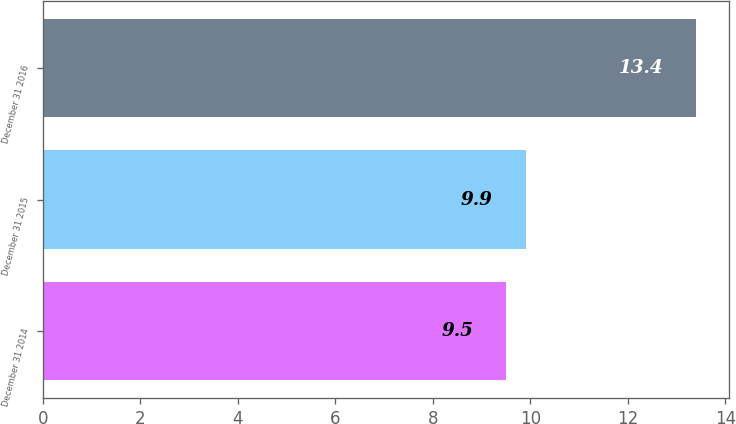Convert chart. <chart><loc_0><loc_0><loc_500><loc_500><bar_chart><fcel>December 31 2014<fcel>December 31 2015<fcel>December 31 2016<nl><fcel>9.5<fcel>9.9<fcel>13.4<nl></chart> 